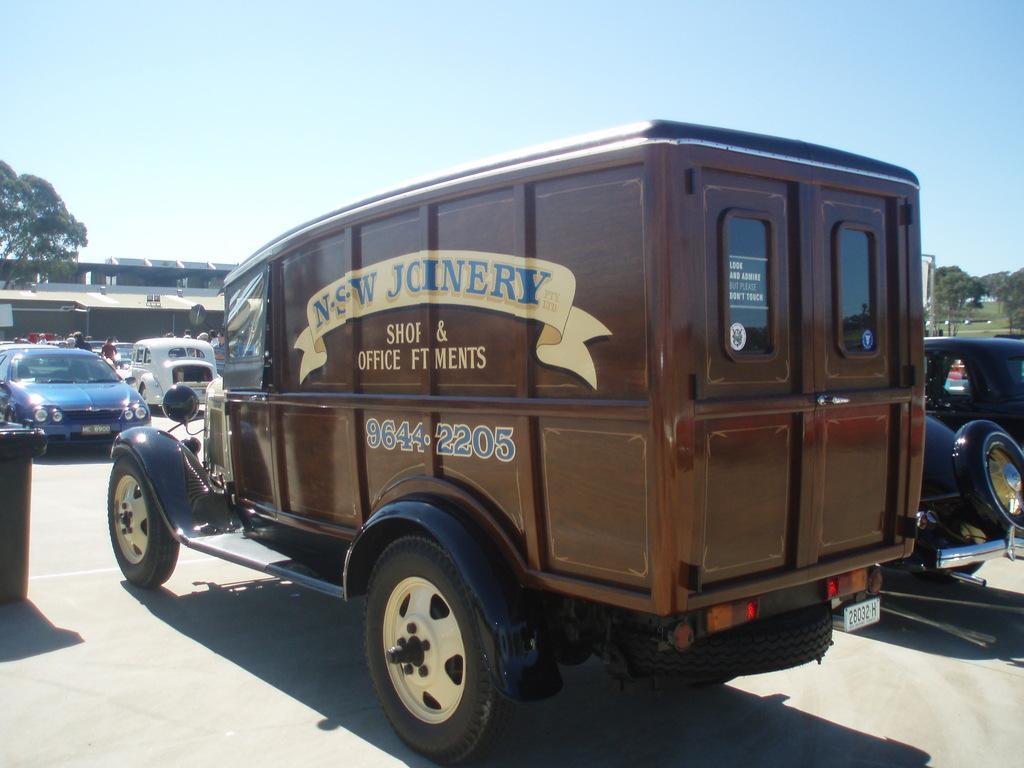Could you give a brief overview of what you see in this image? In this picture we can see vehicles on the road. There are people and we can see rooftops, board, grass and trees. In the background of the image we can see the sky. 